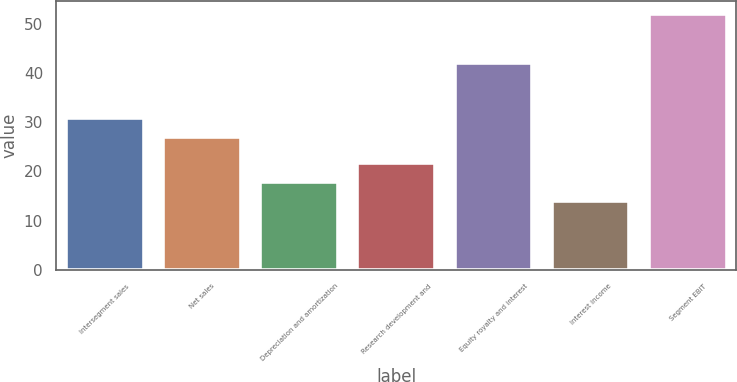Convert chart to OTSL. <chart><loc_0><loc_0><loc_500><loc_500><bar_chart><fcel>Intersegment sales<fcel>Net sales<fcel>Depreciation and amortization<fcel>Research development and<fcel>Equity royalty and interest<fcel>Interest income<fcel>Segment EBIT<nl><fcel>30.8<fcel>27<fcel>17.8<fcel>21.6<fcel>42<fcel>14<fcel>52<nl></chart> 